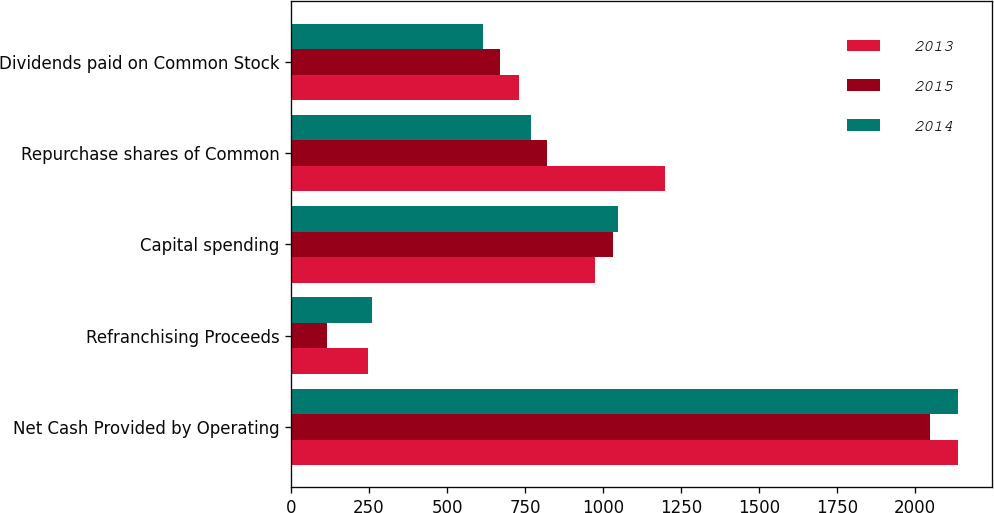Convert chart. <chart><loc_0><loc_0><loc_500><loc_500><stacked_bar_chart><ecel><fcel>Net Cash Provided by Operating<fcel>Refranchising Proceeds<fcel>Capital spending<fcel>Repurchase shares of Common<fcel>Dividends paid on Common Stock<nl><fcel>2013<fcel>2139<fcel>246<fcel>973<fcel>1200<fcel>730<nl><fcel>2015<fcel>2049<fcel>114<fcel>1033<fcel>820<fcel>669<nl><fcel>2014<fcel>2139<fcel>260<fcel>1049<fcel>770<fcel>615<nl></chart> 